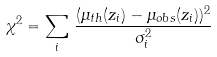<formula> <loc_0><loc_0><loc_500><loc_500>\chi ^ { 2 } = \sum _ { i } \, \frac { ( \mu _ { t h } ( z _ { i } ) - \mu _ { o b s } ( z _ { i } ) ) ^ { 2 } } { \sigma _ { i } ^ { 2 } }</formula> 